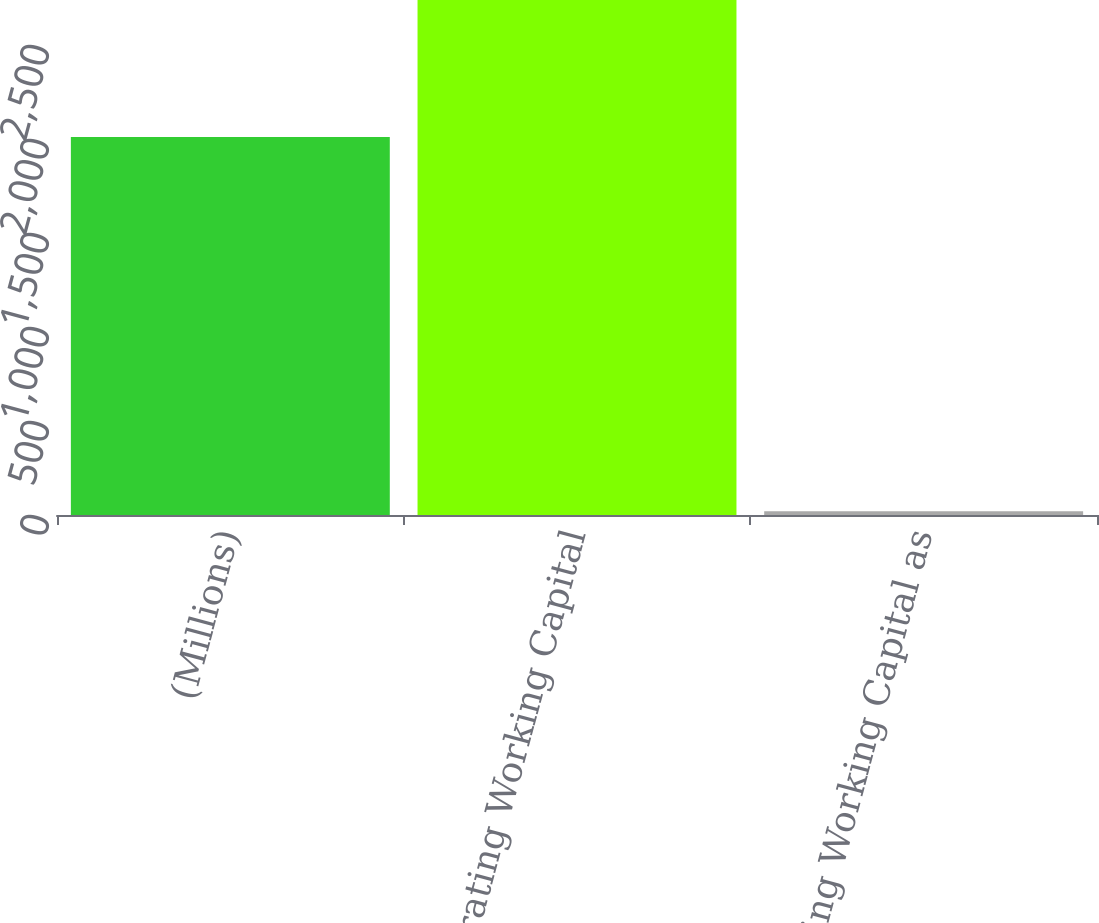Convert chart to OTSL. <chart><loc_0><loc_0><loc_500><loc_500><bar_chart><fcel>(Millions)<fcel>Operating Working Capital<fcel>Operating Working Capital as<nl><fcel>2011<fcel>2739<fcel>19.5<nl></chart> 